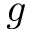Convert formula to latex. <formula><loc_0><loc_0><loc_500><loc_500>g</formula> 